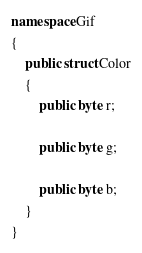<code> <loc_0><loc_0><loc_500><loc_500><_C#_>
namespace Gif
{
	public struct Color
	{
		public byte r;

		public byte g;

		public byte b;
	}
}
</code> 